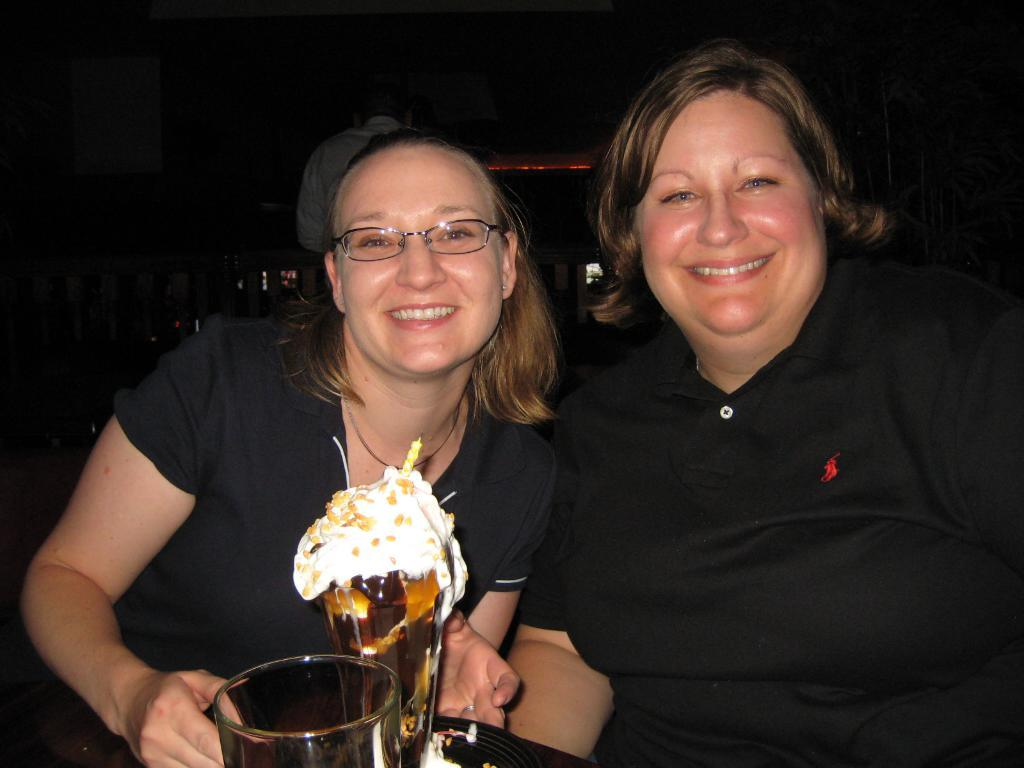How many people are in the image? There are two women in the image. What expressions do the women have? Both women are smiling. What objects are in front of the women? There are glasses in front of the women. What can be observed about the background of the image? The background of the image is dark. What type of van can be seen in the image? There is no van present in the image. How many chins does the woman on the left have? It is not possible to determine the number of chins the woman on the left has from the image, as it does not provide a clear view of her chin. 